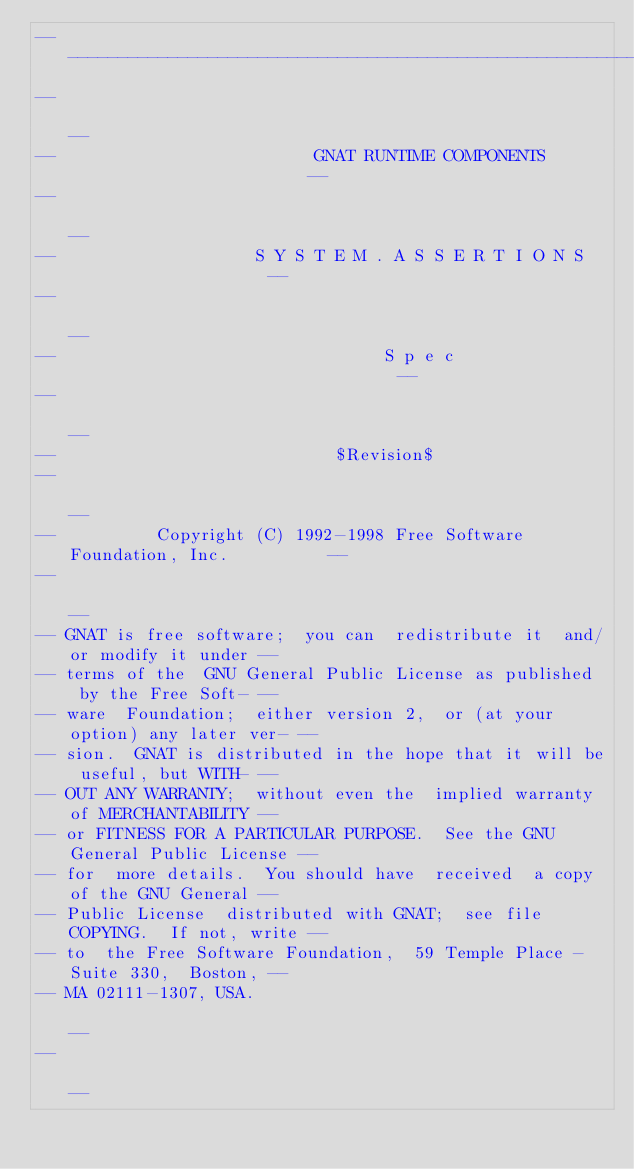Convert code to text. <code><loc_0><loc_0><loc_500><loc_500><_Ada_>------------------------------------------------------------------------------
--                                                                          --
--                          GNAT RUNTIME COMPONENTS                         --
--                                                                          --
--                    S Y S T E M . A S S E R T I O N S                     --
--                                                                          --
--                                 S p e c                                  --
--                                                                          --
--                            $Revision$
--                                                                          --
--          Copyright (C) 1992-1998 Free Software Foundation, Inc.          --
--                                                                          --
-- GNAT is free software;  you can  redistribute it  and/or modify it under --
-- terms of the  GNU General Public License as published  by the Free Soft- --
-- ware  Foundation;  either version 2,  or (at your option) any later ver- --
-- sion.  GNAT is distributed in the hope that it will be useful, but WITH- --
-- OUT ANY WARRANTY;  without even the  implied warranty of MERCHANTABILITY --
-- or FITNESS FOR A PARTICULAR PURPOSE.  See the GNU General Public License --
-- for  more details.  You should have  received  a copy of the GNU General --
-- Public License  distributed with GNAT;  see file COPYING.  If not, write --
-- to  the Free Software Foundation,  59 Temple Place - Suite 330,  Boston, --
-- MA 02111-1307, USA.                                                      --
--                                                                          --</code> 